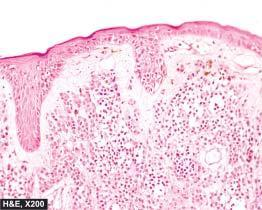s melanin pigment in naevus cells coarse and irregular?
Answer the question using a single word or phrase. Yes 